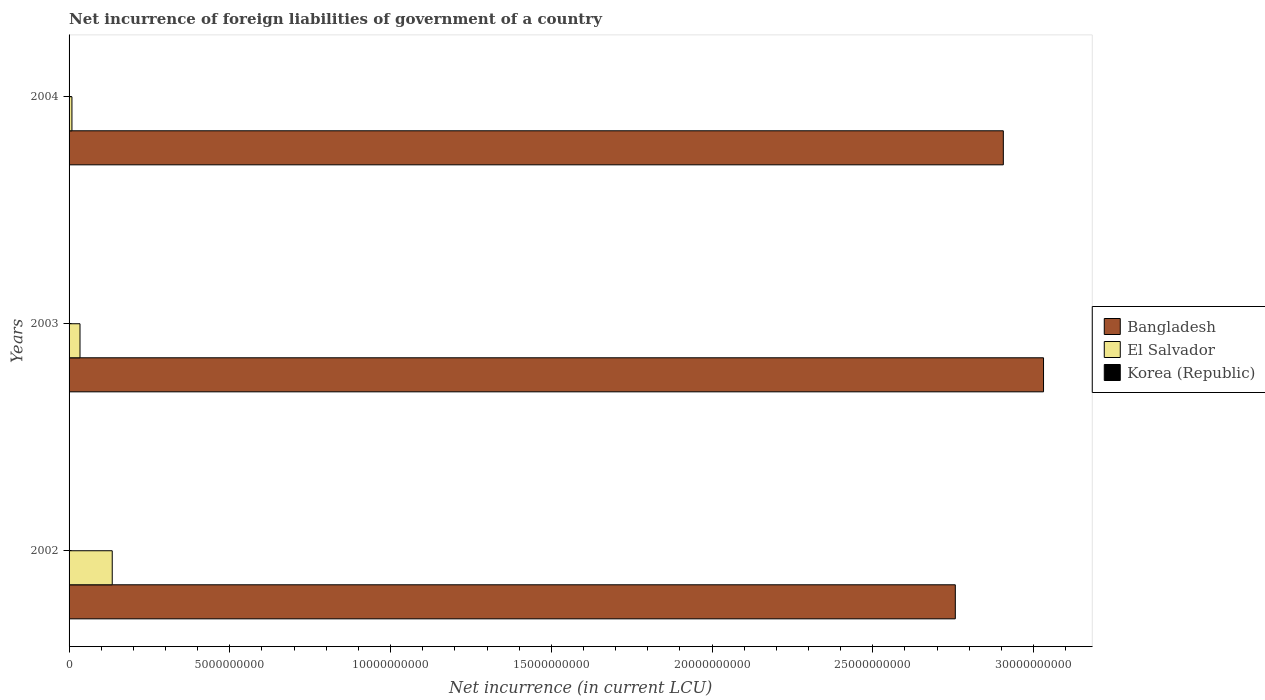How many different coloured bars are there?
Your answer should be very brief. 2. Are the number of bars per tick equal to the number of legend labels?
Your answer should be very brief. No. How many bars are there on the 3rd tick from the top?
Provide a succinct answer. 2. In how many cases, is the number of bars for a given year not equal to the number of legend labels?
Provide a succinct answer. 3. Across all years, what is the minimum net incurrence of foreign liabilities in Korea (Republic)?
Make the answer very short. 0. What is the total net incurrence of foreign liabilities in Bangladesh in the graph?
Make the answer very short. 8.69e+1. What is the difference between the net incurrence of foreign liabilities in Bangladesh in 2002 and that in 2004?
Ensure brevity in your answer.  -1.49e+09. What is the difference between the net incurrence of foreign liabilities in Korea (Republic) in 2003 and the net incurrence of foreign liabilities in El Salvador in 2002?
Provide a succinct answer. -1.34e+09. What is the average net incurrence of foreign liabilities in El Salvador per year?
Make the answer very short. 5.91e+08. In the year 2004, what is the difference between the net incurrence of foreign liabilities in Bangladesh and net incurrence of foreign liabilities in El Salvador?
Keep it short and to the point. 2.90e+1. What is the ratio of the net incurrence of foreign liabilities in Bangladesh in 2002 to that in 2004?
Make the answer very short. 0.95. Is the net incurrence of foreign liabilities in El Salvador in 2002 less than that in 2004?
Make the answer very short. No. What is the difference between the highest and the second highest net incurrence of foreign liabilities in Bangladesh?
Your answer should be very brief. 1.25e+09. What is the difference between the highest and the lowest net incurrence of foreign liabilities in El Salvador?
Make the answer very short. 1.25e+09. Are all the bars in the graph horizontal?
Offer a terse response. Yes. How many years are there in the graph?
Offer a terse response. 3. Does the graph contain grids?
Your answer should be compact. No. How many legend labels are there?
Give a very brief answer. 3. What is the title of the graph?
Offer a very short reply. Net incurrence of foreign liabilities of government of a country. Does "Korea (Republic)" appear as one of the legend labels in the graph?
Keep it short and to the point. Yes. What is the label or title of the X-axis?
Keep it short and to the point. Net incurrence (in current LCU). What is the label or title of the Y-axis?
Give a very brief answer. Years. What is the Net incurrence (in current LCU) in Bangladesh in 2002?
Offer a very short reply. 2.76e+1. What is the Net incurrence (in current LCU) of El Salvador in 2002?
Your response must be concise. 1.34e+09. What is the Net incurrence (in current LCU) in Bangladesh in 2003?
Your response must be concise. 3.03e+1. What is the Net incurrence (in current LCU) in El Salvador in 2003?
Your response must be concise. 3.40e+08. What is the Net incurrence (in current LCU) of Bangladesh in 2004?
Ensure brevity in your answer.  2.91e+1. What is the Net incurrence (in current LCU) of El Salvador in 2004?
Your response must be concise. 8.90e+07. Across all years, what is the maximum Net incurrence (in current LCU) in Bangladesh?
Your answer should be compact. 3.03e+1. Across all years, what is the maximum Net incurrence (in current LCU) in El Salvador?
Ensure brevity in your answer.  1.34e+09. Across all years, what is the minimum Net incurrence (in current LCU) of Bangladesh?
Provide a short and direct response. 2.76e+1. Across all years, what is the minimum Net incurrence (in current LCU) in El Salvador?
Provide a succinct answer. 8.90e+07. What is the total Net incurrence (in current LCU) of Bangladesh in the graph?
Make the answer very short. 8.69e+1. What is the total Net incurrence (in current LCU) in El Salvador in the graph?
Provide a succinct answer. 1.77e+09. What is the difference between the Net incurrence (in current LCU) of Bangladesh in 2002 and that in 2003?
Provide a succinct answer. -2.74e+09. What is the difference between the Net incurrence (in current LCU) in El Salvador in 2002 and that in 2003?
Your response must be concise. 1.00e+09. What is the difference between the Net incurrence (in current LCU) in Bangladesh in 2002 and that in 2004?
Make the answer very short. -1.49e+09. What is the difference between the Net incurrence (in current LCU) in El Salvador in 2002 and that in 2004?
Ensure brevity in your answer.  1.25e+09. What is the difference between the Net incurrence (in current LCU) in Bangladesh in 2003 and that in 2004?
Give a very brief answer. 1.25e+09. What is the difference between the Net incurrence (in current LCU) in El Salvador in 2003 and that in 2004?
Offer a terse response. 2.51e+08. What is the difference between the Net incurrence (in current LCU) of Bangladesh in 2002 and the Net incurrence (in current LCU) of El Salvador in 2003?
Ensure brevity in your answer.  2.72e+1. What is the difference between the Net incurrence (in current LCU) in Bangladesh in 2002 and the Net incurrence (in current LCU) in El Salvador in 2004?
Your response must be concise. 2.75e+1. What is the difference between the Net incurrence (in current LCU) in Bangladesh in 2003 and the Net incurrence (in current LCU) in El Salvador in 2004?
Offer a terse response. 3.02e+1. What is the average Net incurrence (in current LCU) in Bangladesh per year?
Offer a terse response. 2.90e+1. What is the average Net incurrence (in current LCU) of El Salvador per year?
Your answer should be very brief. 5.91e+08. What is the average Net incurrence (in current LCU) in Korea (Republic) per year?
Offer a very short reply. 0. In the year 2002, what is the difference between the Net incurrence (in current LCU) in Bangladesh and Net incurrence (in current LCU) in El Salvador?
Your response must be concise. 2.62e+1. In the year 2003, what is the difference between the Net incurrence (in current LCU) of Bangladesh and Net incurrence (in current LCU) of El Salvador?
Make the answer very short. 3.00e+1. In the year 2004, what is the difference between the Net incurrence (in current LCU) of Bangladesh and Net incurrence (in current LCU) of El Salvador?
Your response must be concise. 2.90e+1. What is the ratio of the Net incurrence (in current LCU) of Bangladesh in 2002 to that in 2003?
Ensure brevity in your answer.  0.91. What is the ratio of the Net incurrence (in current LCU) in El Salvador in 2002 to that in 2003?
Offer a very short reply. 3.95. What is the ratio of the Net incurrence (in current LCU) of Bangladesh in 2002 to that in 2004?
Give a very brief answer. 0.95. What is the ratio of the Net incurrence (in current LCU) of El Salvador in 2002 to that in 2004?
Offer a very short reply. 15.09. What is the ratio of the Net incurrence (in current LCU) in Bangladesh in 2003 to that in 2004?
Provide a succinct answer. 1.04. What is the ratio of the Net incurrence (in current LCU) of El Salvador in 2003 to that in 2004?
Offer a terse response. 3.82. What is the difference between the highest and the second highest Net incurrence (in current LCU) in Bangladesh?
Provide a succinct answer. 1.25e+09. What is the difference between the highest and the second highest Net incurrence (in current LCU) of El Salvador?
Make the answer very short. 1.00e+09. What is the difference between the highest and the lowest Net incurrence (in current LCU) in Bangladesh?
Your response must be concise. 2.74e+09. What is the difference between the highest and the lowest Net incurrence (in current LCU) of El Salvador?
Keep it short and to the point. 1.25e+09. 